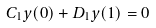Convert formula to latex. <formula><loc_0><loc_0><loc_500><loc_500>C _ { 1 } y ( 0 ) + D _ { 1 } y ( 1 ) = 0</formula> 